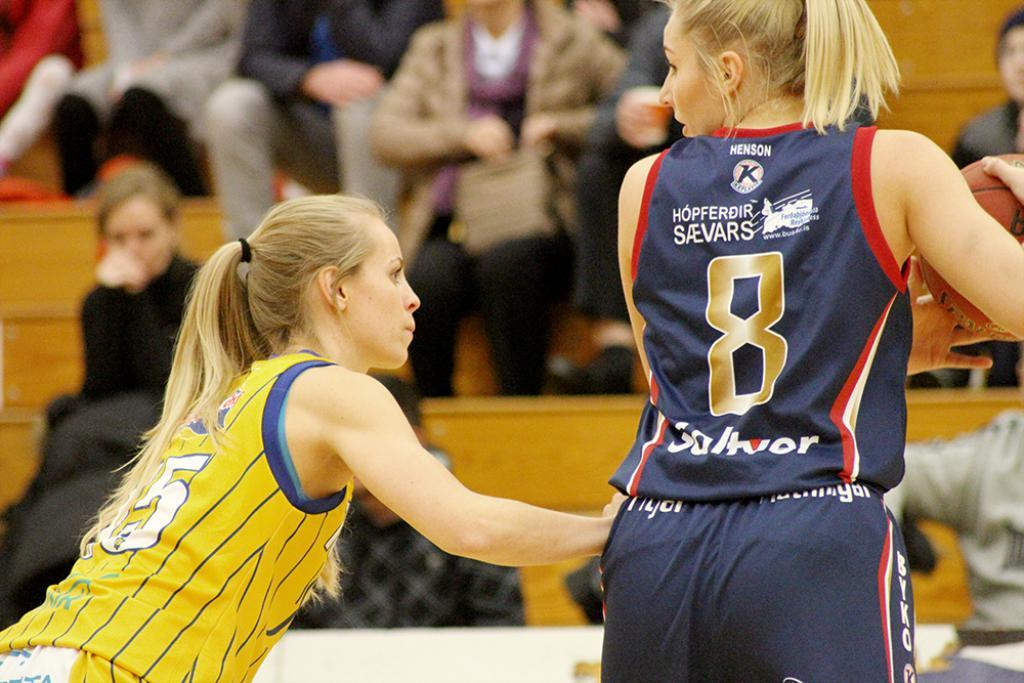Provide a one-sentence caption for the provided image. A female basketball player, wearing the number 8, handles the ball. 